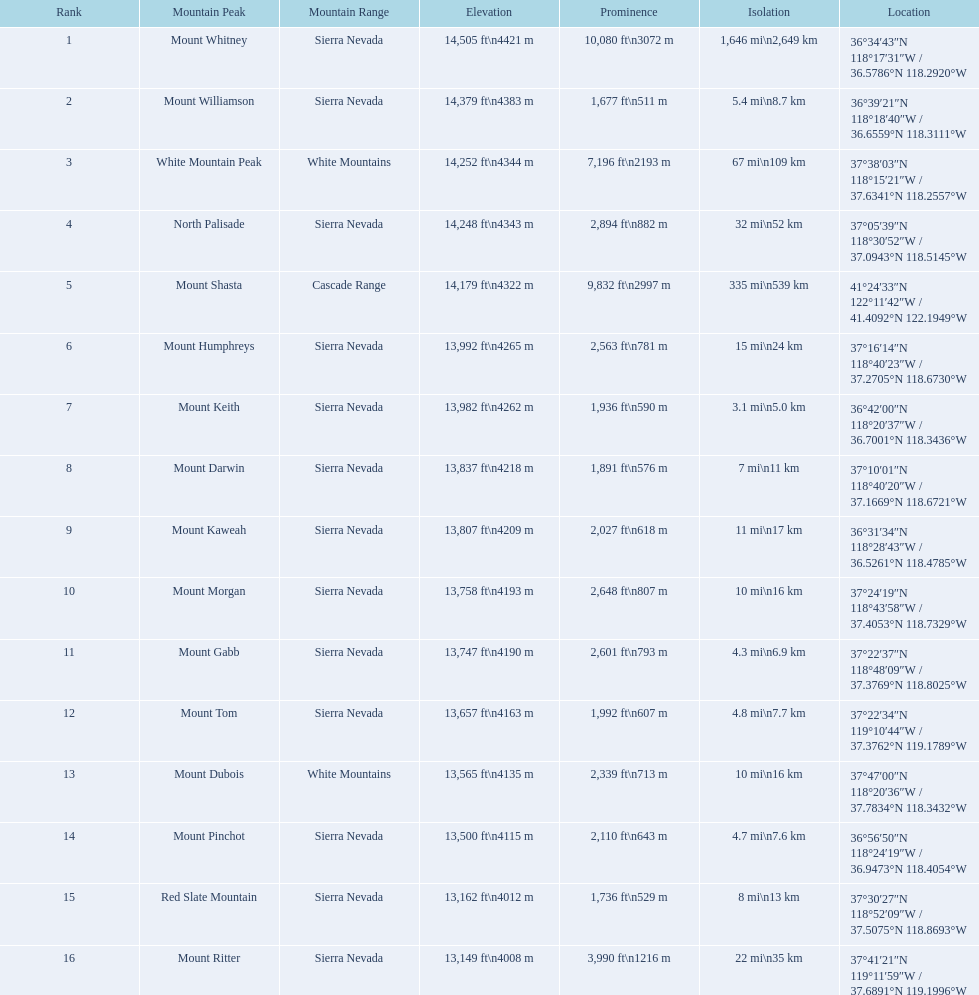What are the prominence elevations over 10,000 feet? 10,080 ft\n3072 m. What mountain pinnacle features a prominence of 10,080 feet? Mount Whitney. 